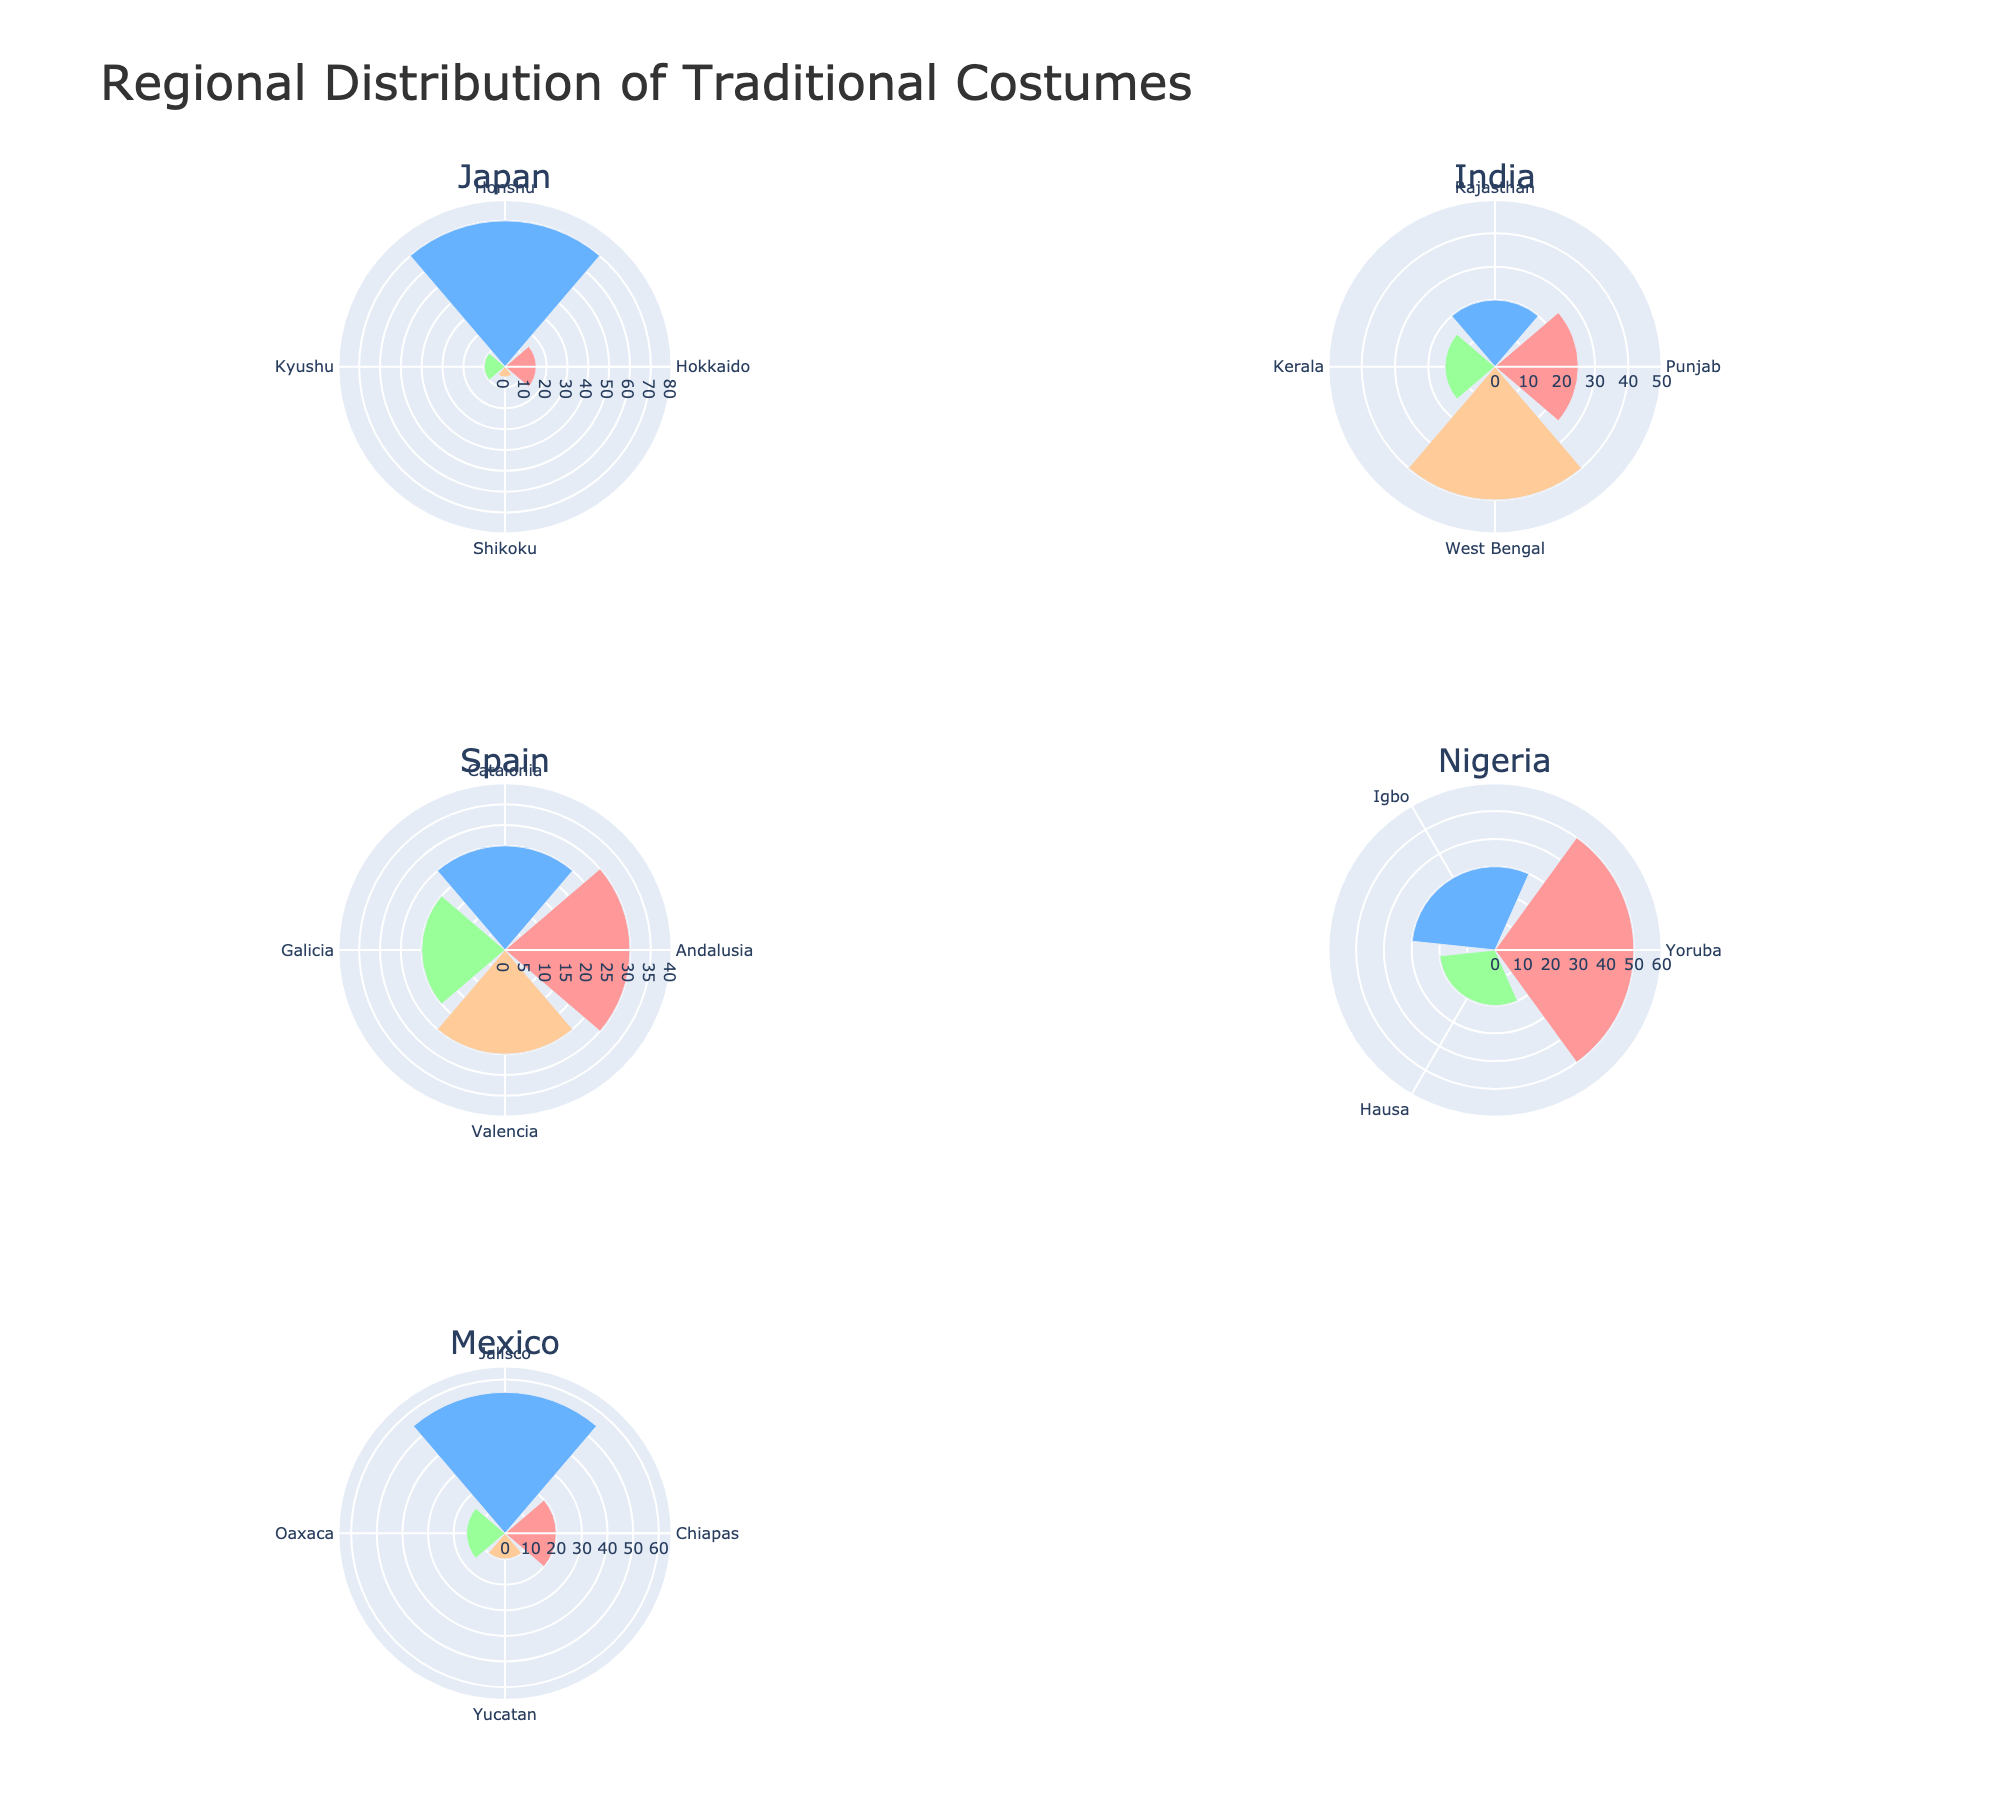what is the title of the plot? The plot's title is displayed at the top center of the figure. It reads "Regional Distribution of Traditional Costumes".
Answer: Regional Distribution of Traditional Costumes Which region in India has the largest percentage distribution of traditional costumes? By looking at the Indian subplots, West Bengal has the largest radial extent, which visually corresponds to the Saree with 40%.
Answer: West Bengal How many regions are shown for Mexico, and what are they? There are four wedges in the Mexico subplot, each representing a different region. The regions listed are Chiapas, Jalisco, Oaxaca, and Yucatan.
Answer: Four. Chiapas, Jalisco, Oaxaca, Yucatan Which country's region has the highest percentage distribution overall and what is it? By examining all subplots, Jalisco in Mexico shows the highest percentage distribution across all regions, represented by the Charro Suit with 55%.
Answer: Jalisco, 55% Compare Japan's Honshu and Nigeria's Yoruba regions in terms of costume distribution percentage. Which one is higher and by how much? Honshu in Japan shows a distribution percentage of 70% for the Kimono, while Yoruba in Nigeria shows 50% for Aso Oke. The difference is 70% - 50% = 20%.
Answer: Honshu is higher by 20% What is the total distribution percentage for Japan's costumes? Adding up the percentages for all Japanese regions: 15% (Hokkaido) + 70% (Honshu) + 10% (Kyushu) + 5% (Shikoku) = 100%.
Answer: 100% Which traditional costume in Spain has the least representation, and what is the percentage? By looking at the Spain subplot, the Traditional Galician Costume in Galicia has the smallest radial extent representing 20%.
Answer: Traditional Galician Costume, 20% If you combine the percentages for Igbo and Hausa regions in Nigeria, what is the result? Add the percentages for Igbo (30%) and Hausa (20%): 30% + 20% = 50%.
Answer: 50% Discuss the contrast in the variety of traditional costumes between India and Nigeria. How many distinct traditional costumes does each country have? Counting the costumes in the subplots for each country, India has four distinct traditional costumes, same as Nigeria.
Answer: Both have four distinct costumes 